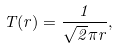Convert formula to latex. <formula><loc_0><loc_0><loc_500><loc_500>T ( r ) = \frac { 1 } { \sqrt { 2 } \pi r } ,</formula> 